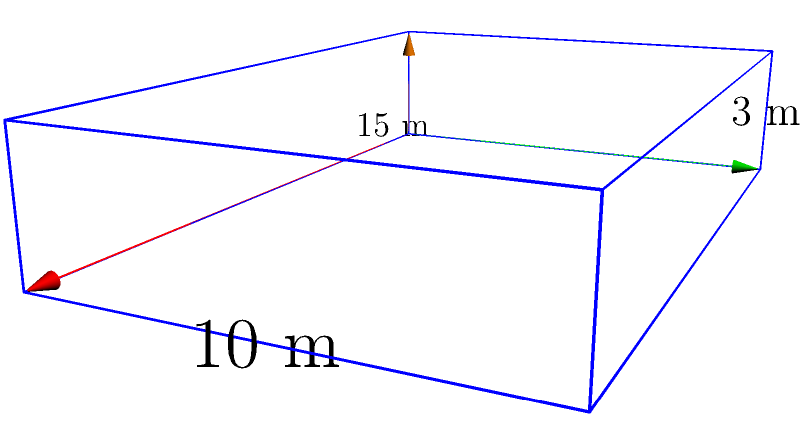Marin Čilić is practicing on a new indoor tennis court. The court is shaped like a rectangular prism with dimensions 15 meters in length, 10 meters in width, and 3 meters in height. What is the volume of this indoor tennis court in cubic meters? To find the volume of a rectangular prism, we need to multiply its length, width, and height.

Given dimensions:
- Length ($l$) = 15 meters
- Width ($w$) = 10 meters
- Height ($h$) = 3 meters

The formula for the volume of a rectangular prism is:

$$V = l \times w \times h$$

Substituting the values:

$$V = 15 \text{ m} \times 10 \text{ m} \times 3 \text{ m}$$

$$V = 450 \text{ m}^3$$

Therefore, the volume of the indoor tennis court is 450 cubic meters.
Answer: 450 m³ 